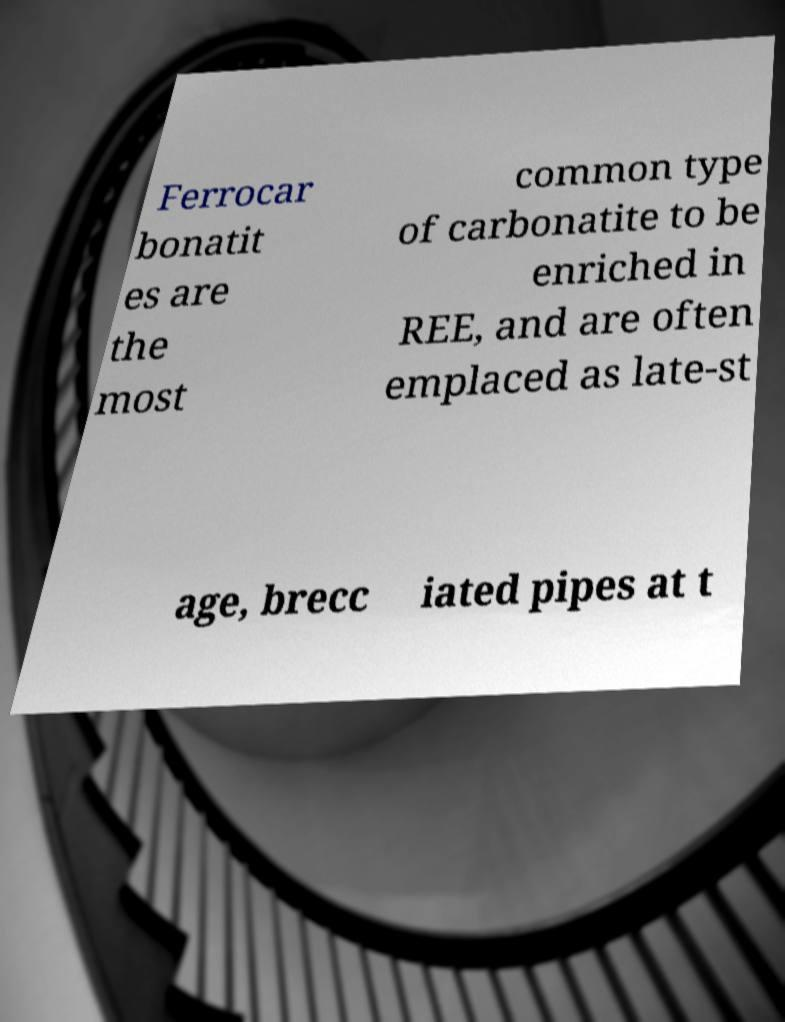Please identify and transcribe the text found in this image. Ferrocar bonatit es are the most common type of carbonatite to be enriched in REE, and are often emplaced as late-st age, brecc iated pipes at t 